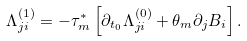Convert formula to latex. <formula><loc_0><loc_0><loc_500><loc_500>\Lambda _ { j i } ^ { ( 1 ) } = - \tau _ { m } ^ { * } \left [ \partial _ { t _ { 0 } } \Lambda _ { j i } ^ { ( 0 ) } + \theta _ { m } \partial _ { j } B _ { i } \right ] .</formula> 